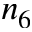Convert formula to latex. <formula><loc_0><loc_0><loc_500><loc_500>n _ { 6 }</formula> 